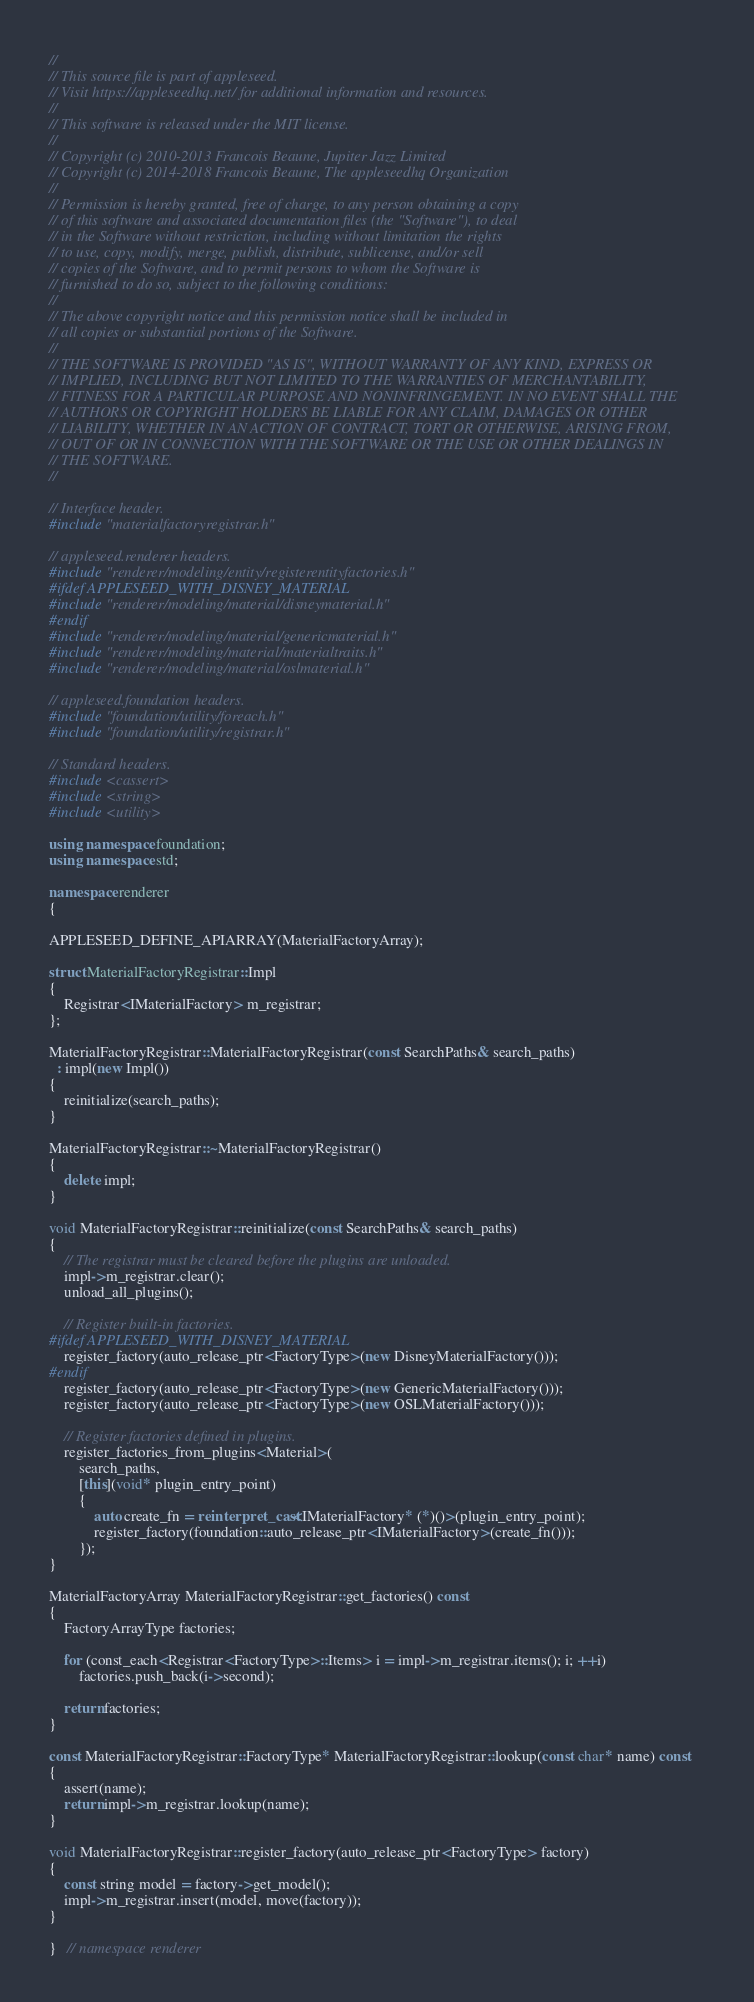Convert code to text. <code><loc_0><loc_0><loc_500><loc_500><_C++_>
//
// This source file is part of appleseed.
// Visit https://appleseedhq.net/ for additional information and resources.
//
// This software is released under the MIT license.
//
// Copyright (c) 2010-2013 Francois Beaune, Jupiter Jazz Limited
// Copyright (c) 2014-2018 Francois Beaune, The appleseedhq Organization
//
// Permission is hereby granted, free of charge, to any person obtaining a copy
// of this software and associated documentation files (the "Software"), to deal
// in the Software without restriction, including without limitation the rights
// to use, copy, modify, merge, publish, distribute, sublicense, and/or sell
// copies of the Software, and to permit persons to whom the Software is
// furnished to do so, subject to the following conditions:
//
// The above copyright notice and this permission notice shall be included in
// all copies or substantial portions of the Software.
//
// THE SOFTWARE IS PROVIDED "AS IS", WITHOUT WARRANTY OF ANY KIND, EXPRESS OR
// IMPLIED, INCLUDING BUT NOT LIMITED TO THE WARRANTIES OF MERCHANTABILITY,
// FITNESS FOR A PARTICULAR PURPOSE AND NONINFRINGEMENT. IN NO EVENT SHALL THE
// AUTHORS OR COPYRIGHT HOLDERS BE LIABLE FOR ANY CLAIM, DAMAGES OR OTHER
// LIABILITY, WHETHER IN AN ACTION OF CONTRACT, TORT OR OTHERWISE, ARISING FROM,
// OUT OF OR IN CONNECTION WITH THE SOFTWARE OR THE USE OR OTHER DEALINGS IN
// THE SOFTWARE.
//

// Interface header.
#include "materialfactoryregistrar.h"

// appleseed.renderer headers.
#include "renderer/modeling/entity/registerentityfactories.h"
#ifdef APPLESEED_WITH_DISNEY_MATERIAL
#include "renderer/modeling/material/disneymaterial.h"
#endif
#include "renderer/modeling/material/genericmaterial.h"
#include "renderer/modeling/material/materialtraits.h"
#include "renderer/modeling/material/oslmaterial.h"

// appleseed.foundation headers.
#include "foundation/utility/foreach.h"
#include "foundation/utility/registrar.h"

// Standard headers.
#include <cassert>
#include <string>
#include <utility>

using namespace foundation;
using namespace std;

namespace renderer
{

APPLESEED_DEFINE_APIARRAY(MaterialFactoryArray);

struct MaterialFactoryRegistrar::Impl
{
    Registrar<IMaterialFactory> m_registrar;
};

MaterialFactoryRegistrar::MaterialFactoryRegistrar(const SearchPaths& search_paths)
  : impl(new Impl())
{
    reinitialize(search_paths);
}

MaterialFactoryRegistrar::~MaterialFactoryRegistrar()
{
    delete impl;
}

void MaterialFactoryRegistrar::reinitialize(const SearchPaths& search_paths)
{
    // The registrar must be cleared before the plugins are unloaded.
    impl->m_registrar.clear();
    unload_all_plugins();

    // Register built-in factories.
#ifdef APPLESEED_WITH_DISNEY_MATERIAL
    register_factory(auto_release_ptr<FactoryType>(new DisneyMaterialFactory()));
#endif
    register_factory(auto_release_ptr<FactoryType>(new GenericMaterialFactory()));
    register_factory(auto_release_ptr<FactoryType>(new OSLMaterialFactory()));

    // Register factories defined in plugins.
    register_factories_from_plugins<Material>(
        search_paths,
        [this](void* plugin_entry_point)
        {
            auto create_fn = reinterpret_cast<IMaterialFactory* (*)()>(plugin_entry_point);
            register_factory(foundation::auto_release_ptr<IMaterialFactory>(create_fn()));
        });
}

MaterialFactoryArray MaterialFactoryRegistrar::get_factories() const
{
    FactoryArrayType factories;

    for (const_each<Registrar<FactoryType>::Items> i = impl->m_registrar.items(); i; ++i)
        factories.push_back(i->second);

    return factories;
}

const MaterialFactoryRegistrar::FactoryType* MaterialFactoryRegistrar::lookup(const char* name) const
{
    assert(name);
    return impl->m_registrar.lookup(name);
}

void MaterialFactoryRegistrar::register_factory(auto_release_ptr<FactoryType> factory)
{
    const string model = factory->get_model();
    impl->m_registrar.insert(model, move(factory));
}

}   // namespace renderer
</code> 